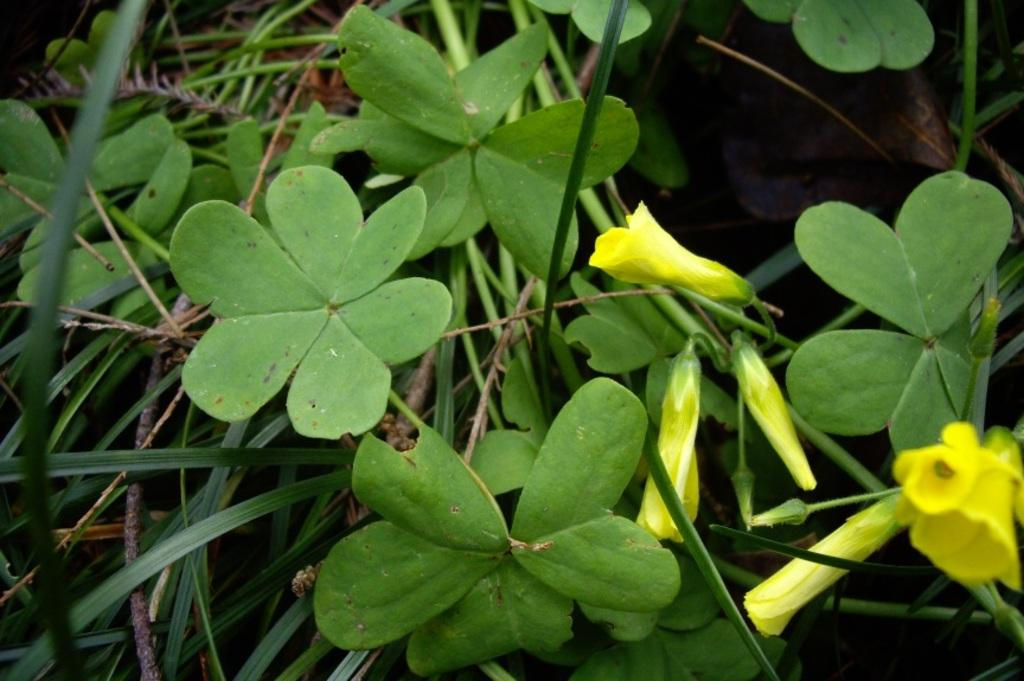What type of living organisms can be seen in the image? Plants and flowers are visible in the image. What color are the flowers in the image? The flowers in the image are yellow in color. What statement can be seen written on the flowers in the image? There are no statements written on the flowers in the image; they are simply flowers. Can you see any fairies interacting with the flowers in the image? There are no fairies present in the image; it only features plants and flowers. 